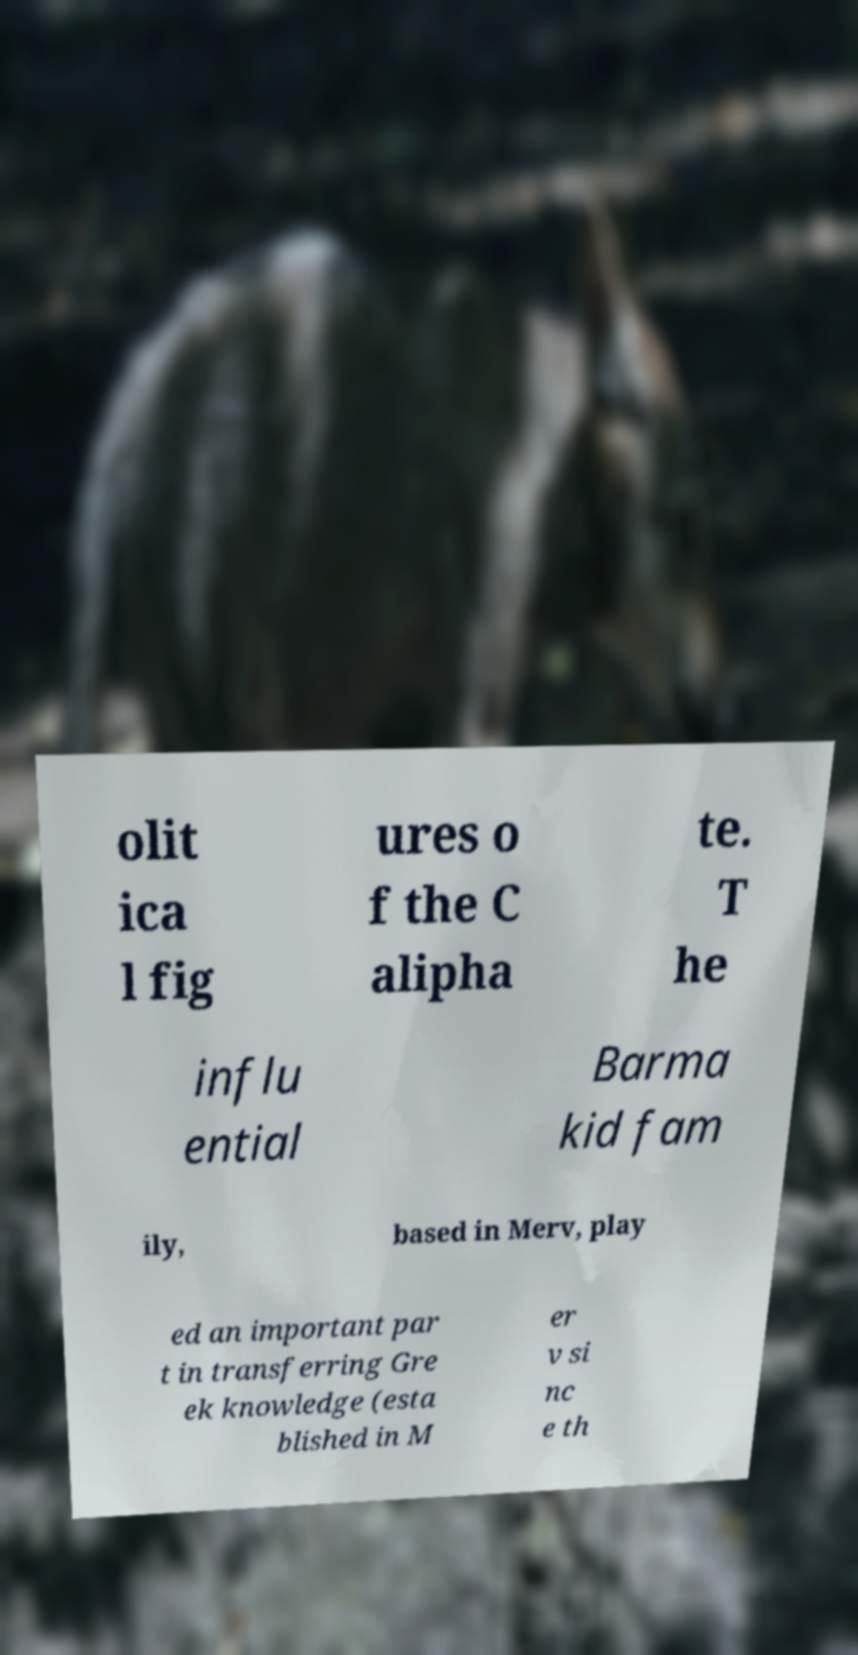Could you assist in decoding the text presented in this image and type it out clearly? olit ica l fig ures o f the C alipha te. T he influ ential Barma kid fam ily, based in Merv, play ed an important par t in transferring Gre ek knowledge (esta blished in M er v si nc e th 